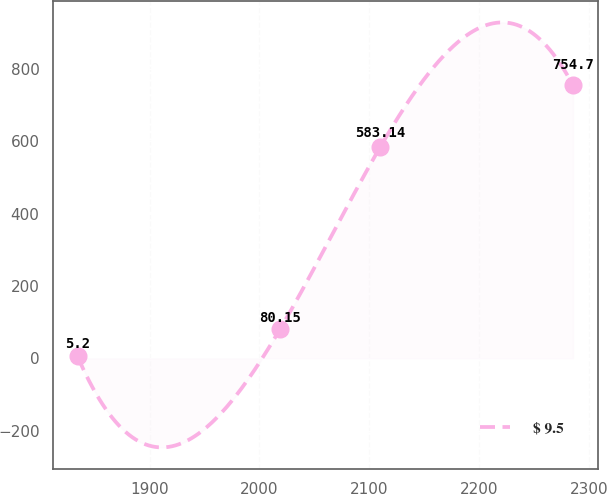Convert chart. <chart><loc_0><loc_0><loc_500><loc_500><line_chart><ecel><fcel>$ 9.5<nl><fcel>1834.44<fcel>5.2<nl><fcel>2018.74<fcel>80.15<nl><fcel>2109.89<fcel>583.14<nl><fcel>2285.46<fcel>754.7<nl></chart> 